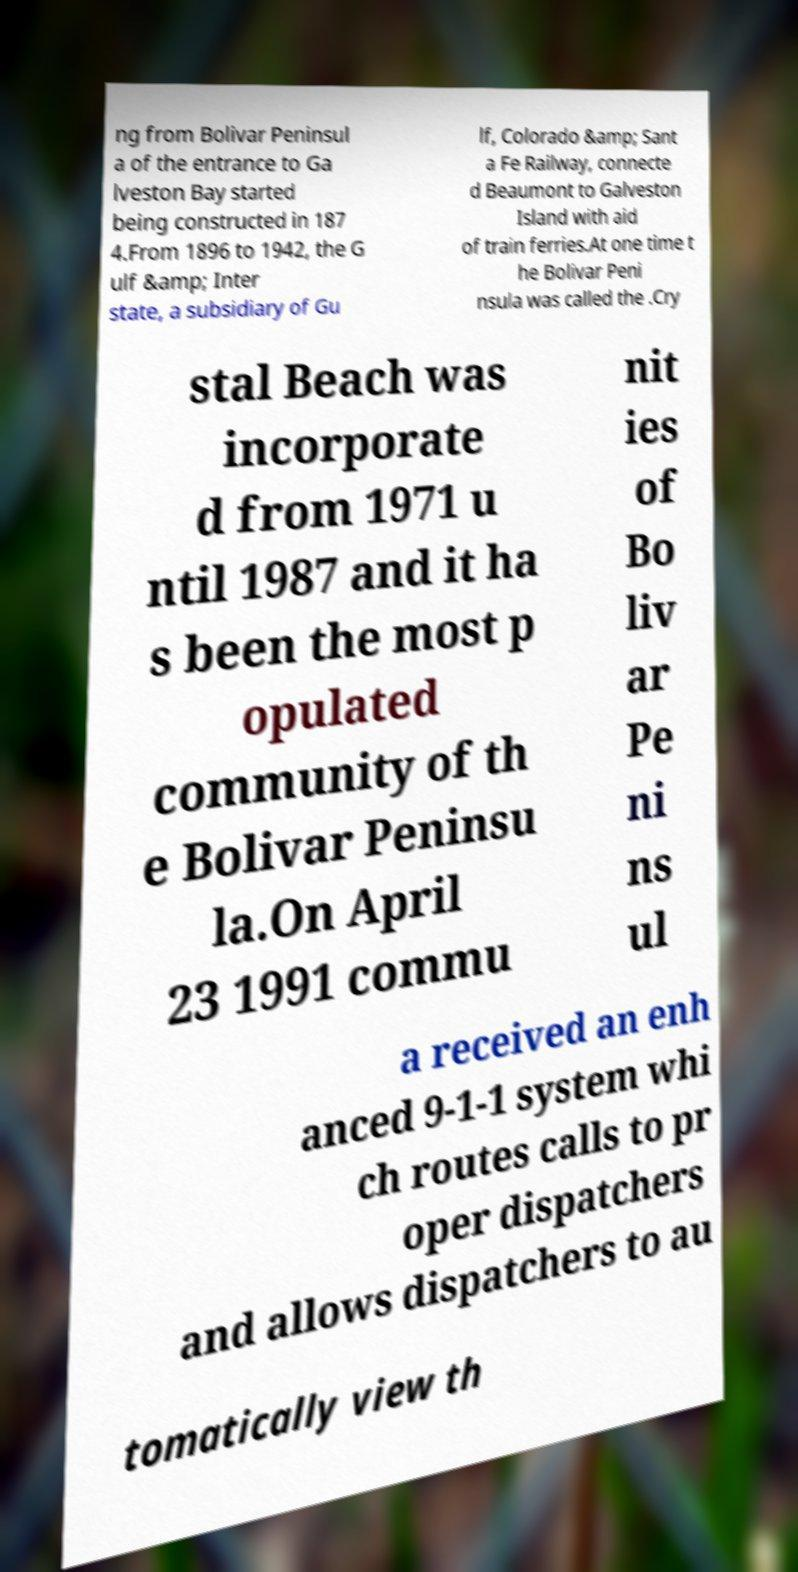Please identify and transcribe the text found in this image. ng from Bolivar Peninsul a of the entrance to Ga lveston Bay started being constructed in 187 4.From 1896 to 1942, the G ulf &amp; Inter state, a subsidiary of Gu lf, Colorado &amp; Sant a Fe Railway, connecte d Beaumont to Galveston Island with aid of train ferries.At one time t he Bolivar Peni nsula was called the .Cry stal Beach was incorporate d from 1971 u ntil 1987 and it ha s been the most p opulated community of th e Bolivar Peninsu la.On April 23 1991 commu nit ies of Bo liv ar Pe ni ns ul a received an enh anced 9-1-1 system whi ch routes calls to pr oper dispatchers and allows dispatchers to au tomatically view th 